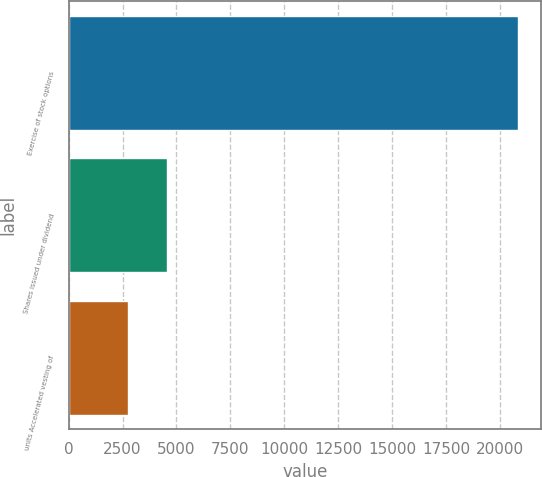Convert chart to OTSL. <chart><loc_0><loc_0><loc_500><loc_500><bar_chart><fcel>Exercise of stock options<fcel>Shares issued under dividend<fcel>units Accelerated vesting of<nl><fcel>20857<fcel>4577.8<fcel>2769<nl></chart> 